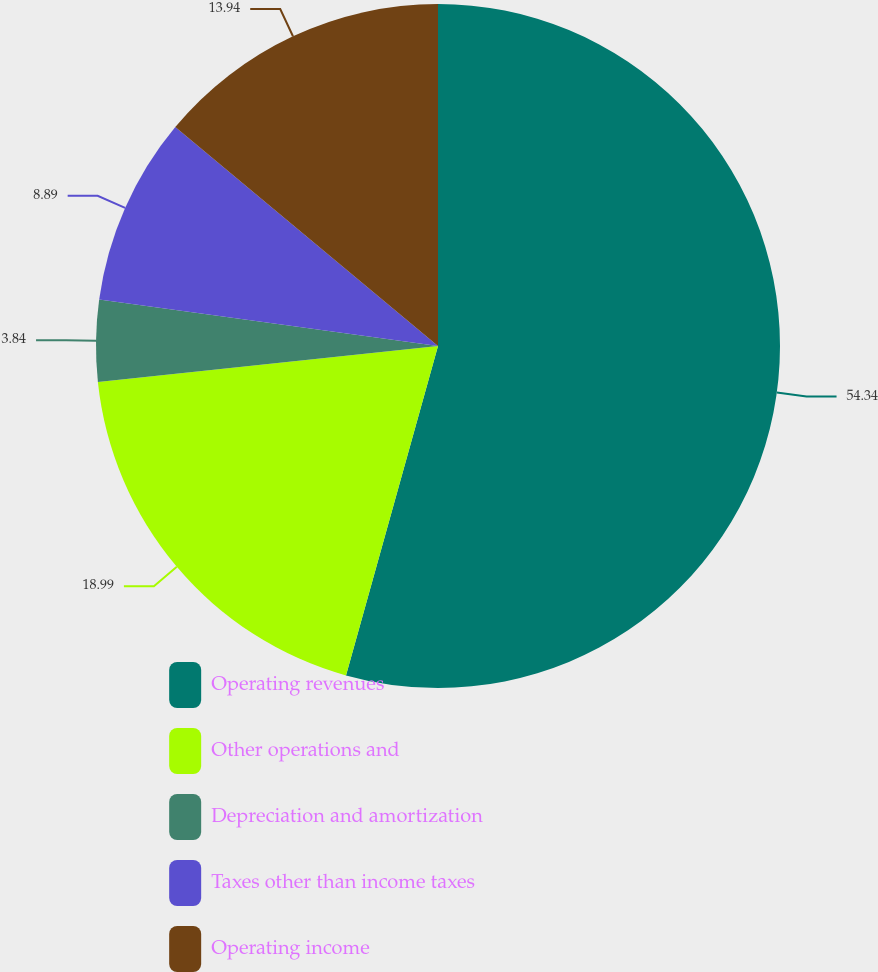Convert chart to OTSL. <chart><loc_0><loc_0><loc_500><loc_500><pie_chart><fcel>Operating revenues<fcel>Other operations and<fcel>Depreciation and amortization<fcel>Taxes other than income taxes<fcel>Operating income<nl><fcel>54.33%<fcel>18.99%<fcel>3.84%<fcel>8.89%<fcel>13.94%<nl></chart> 